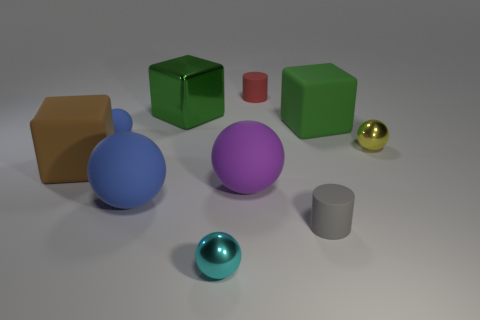How many tiny blue balls are the same material as the big brown object? There is one tiny blue ball that appears to be made of the same glossy material as the big brown object. 